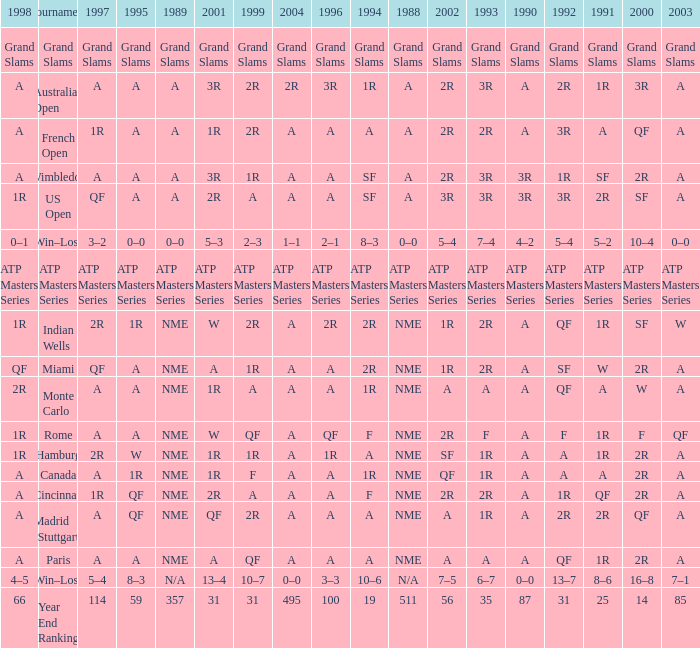Write the full table. {'header': ['1998', 'Tournament', '1997', '1995', '1989', '2001', '1999', '2004', '1996', '1994', '1988', '2002', '1993', '1990', '1992', '1991', '2000', '2003'], 'rows': [['Grand Slams', 'Grand Slams', 'Grand Slams', 'Grand Slams', 'Grand Slams', 'Grand Slams', 'Grand Slams', 'Grand Slams', 'Grand Slams', 'Grand Slams', 'Grand Slams', 'Grand Slams', 'Grand Slams', 'Grand Slams', 'Grand Slams', 'Grand Slams', 'Grand Slams', 'Grand Slams'], ['A', 'Australian Open', 'A', 'A', 'A', '3R', '2R', '2R', '3R', '1R', 'A', '2R', '3R', 'A', '2R', '1R', '3R', 'A'], ['A', 'French Open', '1R', 'A', 'A', '1R', '2R', 'A', 'A', 'A', 'A', '2R', '2R', 'A', '3R', 'A', 'QF', 'A'], ['A', 'Wimbledon', 'A', 'A', 'A', '3R', '1R', 'A', 'A', 'SF', 'A', '2R', '3R', '3R', '1R', 'SF', '2R', 'A'], ['1R', 'US Open', 'QF', 'A', 'A', '2R', 'A', 'A', 'A', 'SF', 'A', '3R', '3R', '3R', '3R', '2R', 'SF', 'A'], ['0–1', 'Win–Loss', '3–2', '0–0', '0–0', '5–3', '2–3', '1–1', '2–1', '8–3', '0–0', '5–4', '7–4', '4–2', '5–4', '5–2', '10–4', '0–0'], ['ATP Masters Series', 'ATP Masters Series', 'ATP Masters Series', 'ATP Masters Series', 'ATP Masters Series', 'ATP Masters Series', 'ATP Masters Series', 'ATP Masters Series', 'ATP Masters Series', 'ATP Masters Series', 'ATP Masters Series', 'ATP Masters Series', 'ATP Masters Series', 'ATP Masters Series', 'ATP Masters Series', 'ATP Masters Series', 'ATP Masters Series', 'ATP Masters Series'], ['1R', 'Indian Wells', '2R', '1R', 'NME', 'W', '2R', 'A', '2R', '2R', 'NME', '1R', '2R', 'A', 'QF', '1R', 'SF', 'W'], ['QF', 'Miami', 'QF', 'A', 'NME', 'A', '1R', 'A', 'A', '2R', 'NME', '1R', '2R', 'A', 'SF', 'W', '2R', 'A'], ['2R', 'Monte Carlo', 'A', 'A', 'NME', '1R', 'A', 'A', 'A', '1R', 'NME', 'A', 'A', 'A', 'QF', 'A', 'W', 'A'], ['1R', 'Rome', 'A', 'A', 'NME', 'W', 'QF', 'A', 'QF', 'F', 'NME', '2R', 'F', 'A', 'F', '1R', 'F', 'QF'], ['1R', 'Hamburg', '2R', 'W', 'NME', '1R', '1R', 'A', '1R', 'A', 'NME', 'SF', '1R', 'A', 'A', '1R', '2R', 'A'], ['A', 'Canada', 'A', '1R', 'NME', '1R', 'F', 'A', 'A', '1R', 'NME', 'QF', '1R', 'A', 'A', 'A', '2R', 'A'], ['A', 'Cincinnati', '1R', 'QF', 'NME', '2R', 'A', 'A', 'A', 'F', 'NME', '2R', '2R', 'A', '1R', 'QF', '2R', 'A'], ['A', 'Madrid (Stuttgart)', 'A', 'QF', 'NME', 'QF', '2R', 'A', 'A', 'A', 'NME', 'A', '1R', 'A', '2R', '2R', 'QF', 'A'], ['A', 'Paris', 'A', 'A', 'NME', 'A', 'QF', 'A', 'A', 'A', 'NME', 'A', 'A', 'A', 'QF', '1R', '2R', 'A'], ['4–5', 'Win–Loss', '5–4', '8–3', 'N/A', '13–4', '10–7', '0–0', '3–3', '10–6', 'N/A', '7–5', '6–7', '0–0', '13–7', '8–6', '16–8', '7–1'], ['66', 'Year End Ranking', '114', '59', '357', '31', '31', '495', '100', '19', '511', '56', '35', '87', '31', '25', '14', '85']]} What shows for 1988 when 1994 shows 10–6? N/A. 